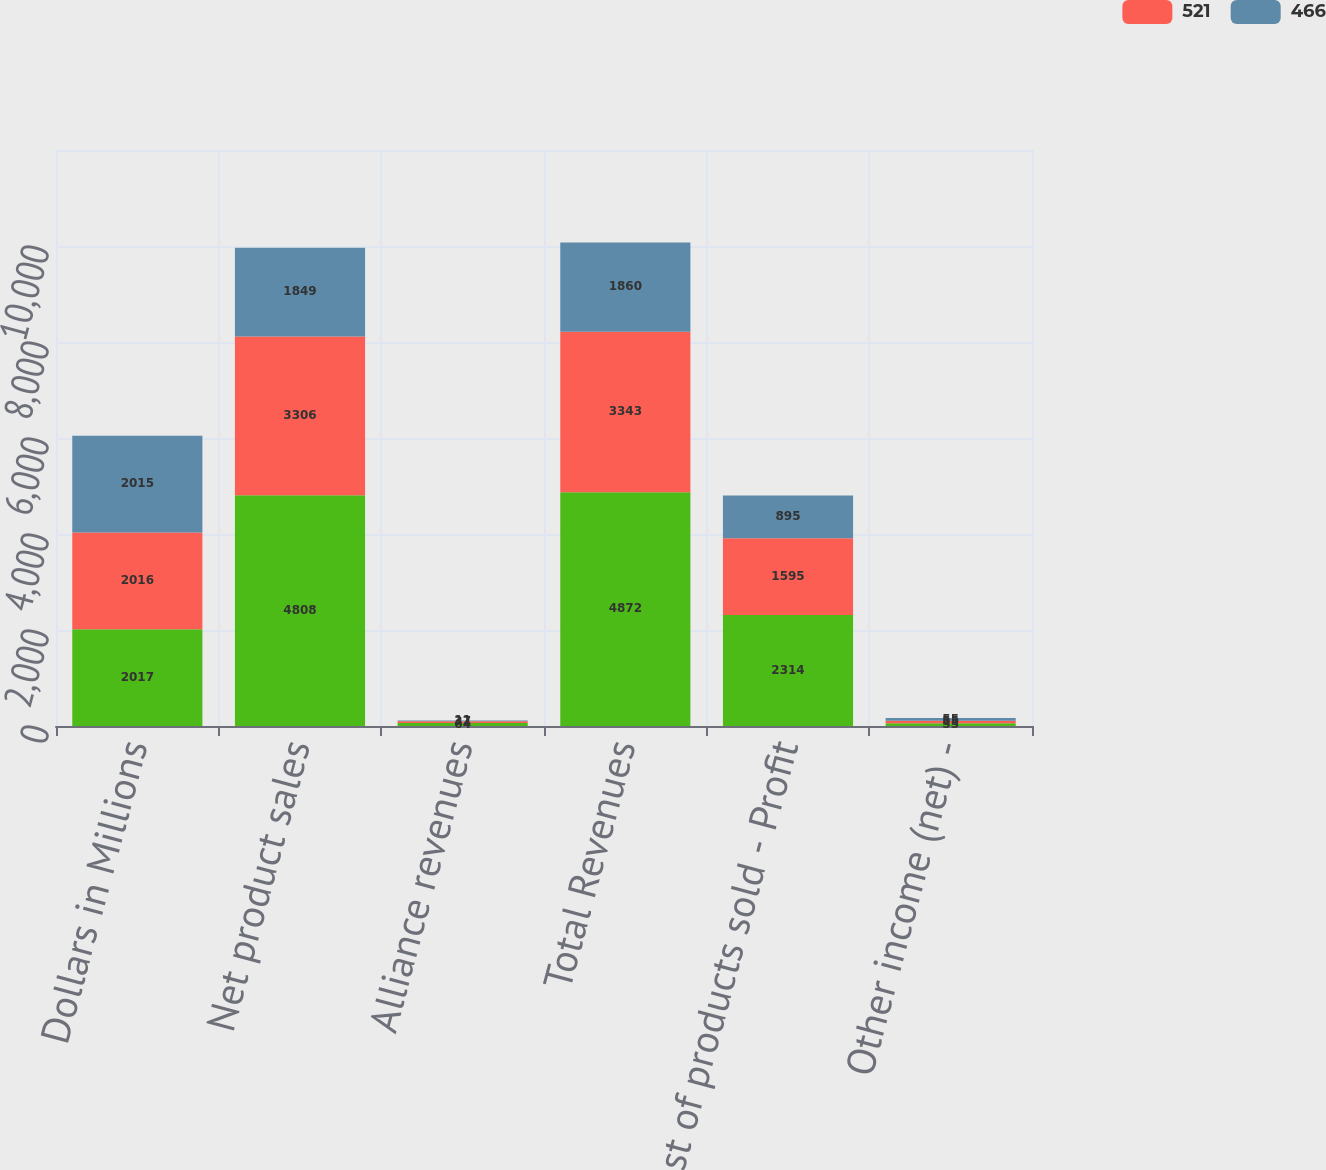Convert chart. <chart><loc_0><loc_0><loc_500><loc_500><stacked_bar_chart><ecel><fcel>Dollars in Millions<fcel>Net product sales<fcel>Alliance revenues<fcel>Total Revenues<fcel>Cost of products sold - Profit<fcel>Other income (net) -<nl><fcel>nan<fcel>2017<fcel>4808<fcel>64<fcel>4872<fcel>2314<fcel>55<nl><fcel>521<fcel>2016<fcel>3306<fcel>37<fcel>3343<fcel>1595<fcel>55<nl><fcel>466<fcel>2015<fcel>1849<fcel>11<fcel>1860<fcel>895<fcel>55<nl></chart> 